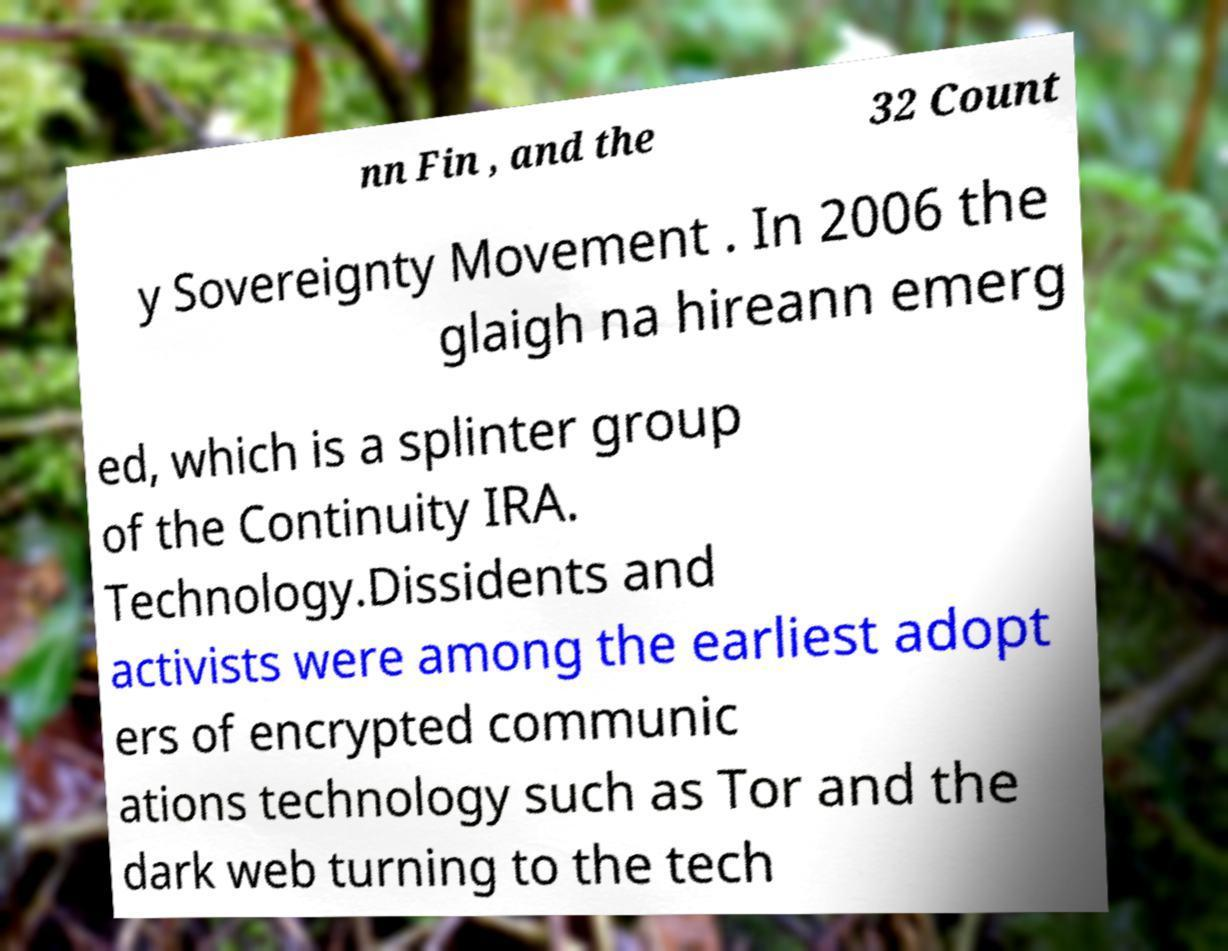There's text embedded in this image that I need extracted. Can you transcribe it verbatim? nn Fin , and the 32 Count y Sovereignty Movement . In 2006 the glaigh na hireann emerg ed, which is a splinter group of the Continuity IRA. Technology.Dissidents and activists were among the earliest adopt ers of encrypted communic ations technology such as Tor and the dark web turning to the tech 